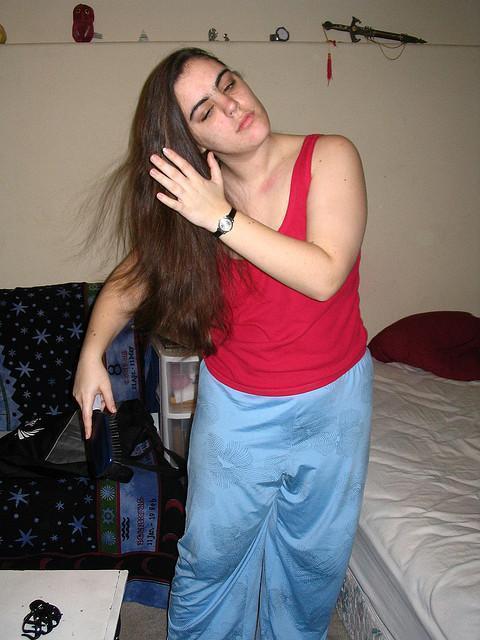What item hanging on the wall would help most on a battlefield?
Answer the question by selecting the correct answer among the 4 following choices and explain your choice with a short sentence. The answer should be formatted with the following format: `Answer: choice
Rationale: rationale.`
Options: Blunderbuss, bazooka, dagger, watch. Answer: dagger.
Rationale: The item is too short to be a sword, and is pointed with a handle. 